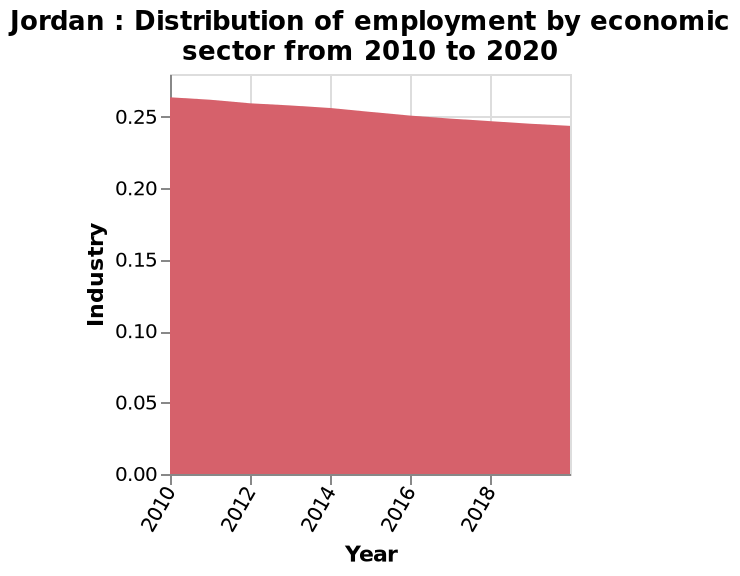<image>
What is the timeframe covered in the Jordan area diagram? The area diagram covers the period from 2010 to 2020. 